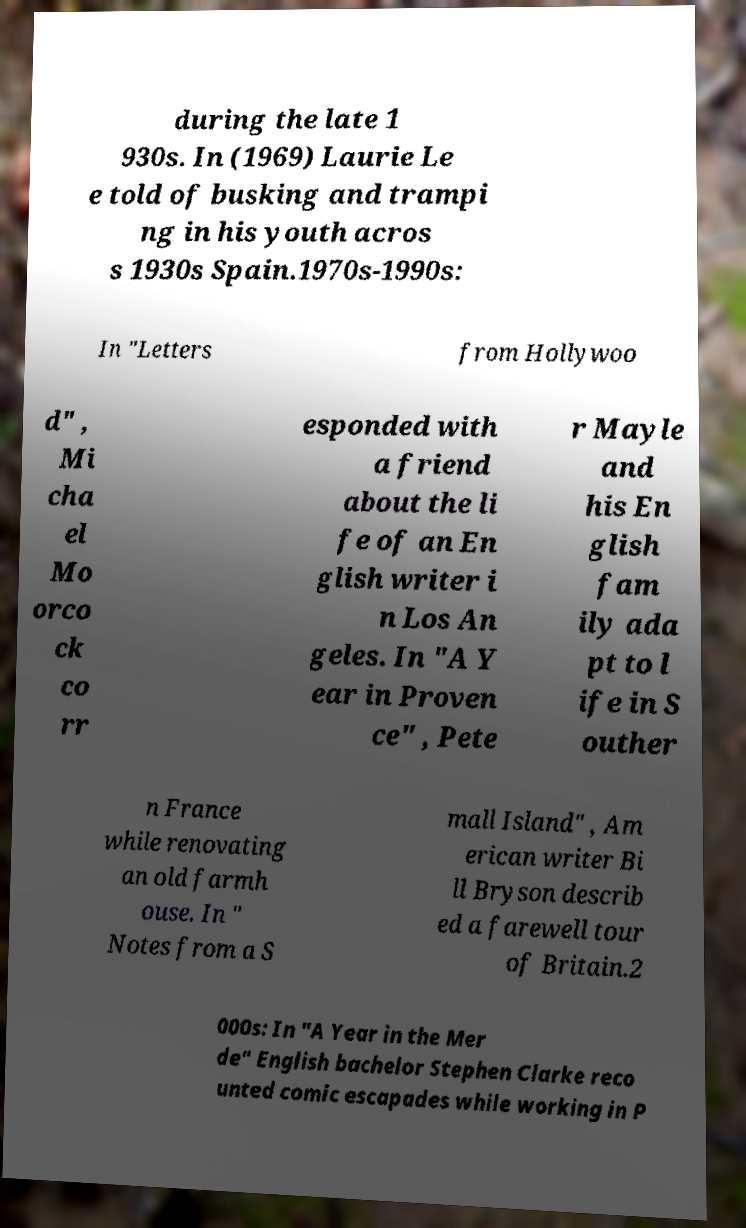Can you accurately transcribe the text from the provided image for me? during the late 1 930s. In (1969) Laurie Le e told of busking and trampi ng in his youth acros s 1930s Spain.1970s-1990s: In "Letters from Hollywoo d" , Mi cha el Mo orco ck co rr esponded with a friend about the li fe of an En glish writer i n Los An geles. In "A Y ear in Proven ce" , Pete r Mayle and his En glish fam ily ada pt to l ife in S outher n France while renovating an old farmh ouse. In " Notes from a S mall Island" , Am erican writer Bi ll Bryson describ ed a farewell tour of Britain.2 000s: In "A Year in the Mer de" English bachelor Stephen Clarke reco unted comic escapades while working in P 